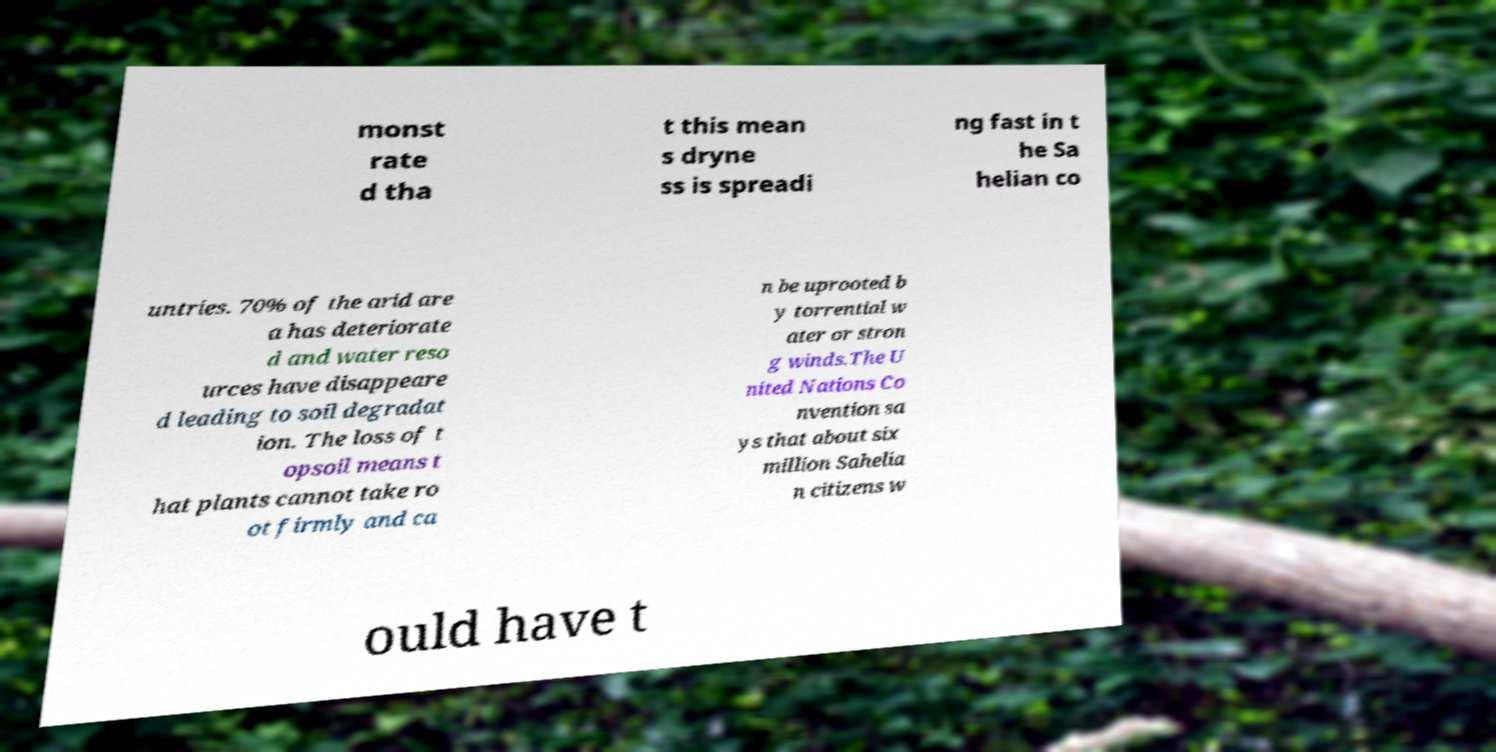Please identify and transcribe the text found in this image. monst rate d tha t this mean s dryne ss is spreadi ng fast in t he Sa helian co untries. 70% of the arid are a has deteriorate d and water reso urces have disappeare d leading to soil degradat ion. The loss of t opsoil means t hat plants cannot take ro ot firmly and ca n be uprooted b y torrential w ater or stron g winds.The U nited Nations Co nvention sa ys that about six million Sahelia n citizens w ould have t 